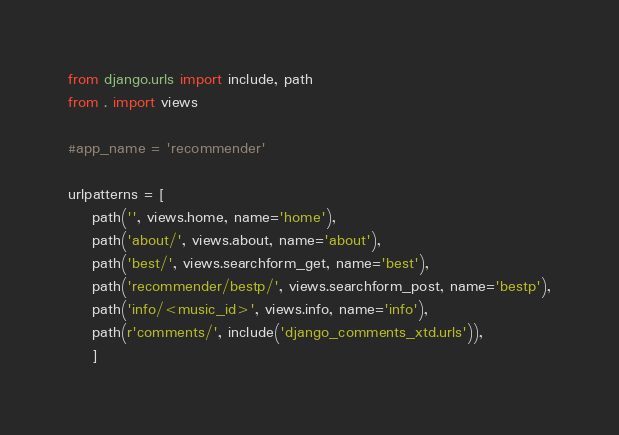Convert code to text. <code><loc_0><loc_0><loc_500><loc_500><_Python_>from django.urls import include, path
from . import views

#app_name = 'recommender'

urlpatterns = [
    path('', views.home, name='home'),
    path('about/', views.about, name='about'),
    path('best/', views.searchform_get, name='best'),
    path('recommender/bestp/', views.searchform_post, name='bestp'),
    path('info/<music_id>', views.info, name='info'),
    path(r'comments/', include('django_comments_xtd.urls')),
    ]
</code> 